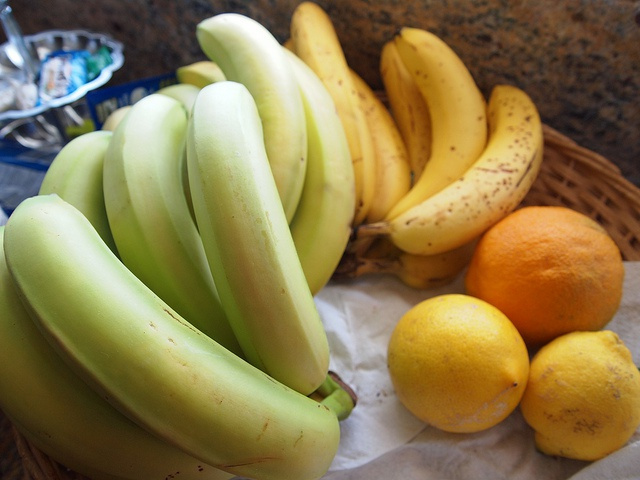Describe the objects in this image and their specific colors. I can see banana in gray, olive, beige, and khaki tones, orange in gray, brown, orange, and maroon tones, orange in gray, olive, orange, and khaki tones, banana in gray, tan, olive, khaki, and orange tones, and orange in gray, olive, orange, tan, and khaki tones in this image. 